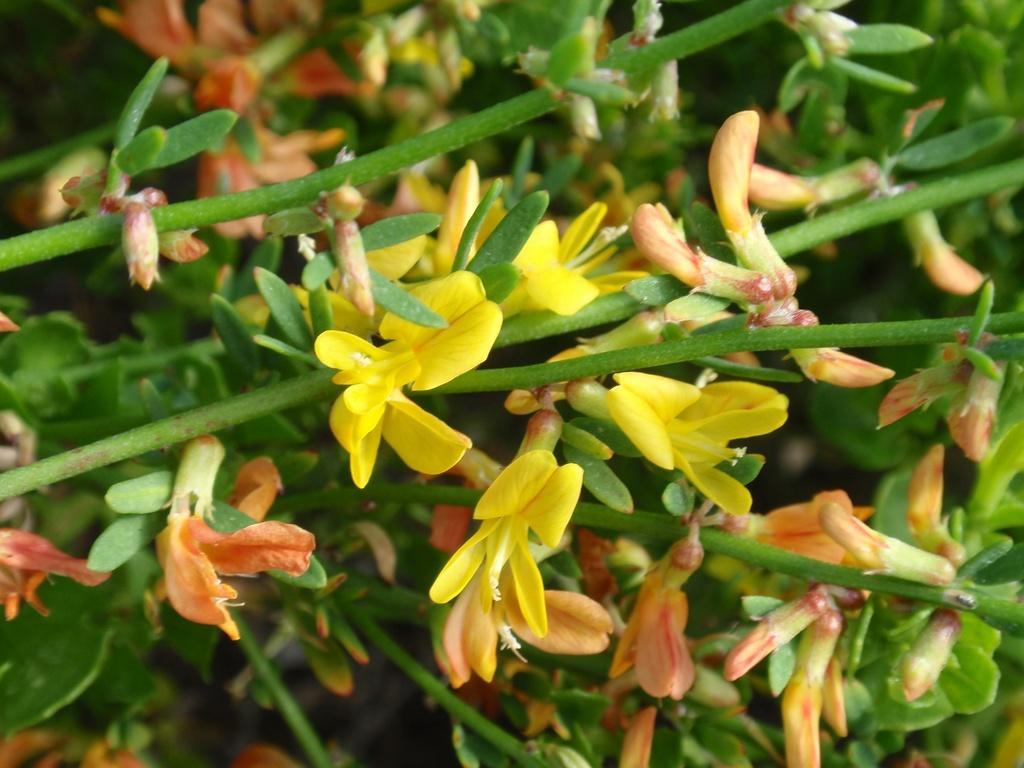In one or two sentences, can you explain what this image depicts? In this image I can see few flowers in orange and yellow color and I can see leaves in green color. 